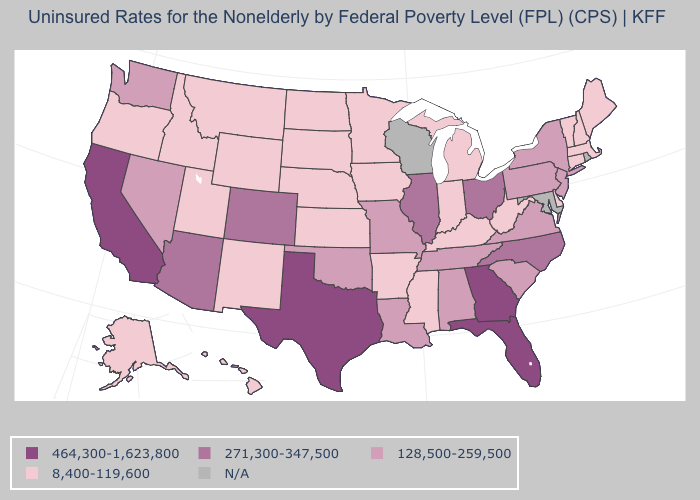What is the lowest value in states that border Oregon?
Answer briefly. 8,400-119,600. Name the states that have a value in the range 8,400-119,600?
Be succinct. Alaska, Arkansas, Connecticut, Delaware, Hawaii, Idaho, Indiana, Iowa, Kansas, Kentucky, Maine, Massachusetts, Michigan, Minnesota, Mississippi, Montana, Nebraska, New Hampshire, New Mexico, North Dakota, Oregon, South Dakota, Utah, Vermont, West Virginia, Wyoming. Among the states that border South Carolina , which have the highest value?
Keep it brief. Georgia. Among the states that border New York , which have the highest value?
Quick response, please. New Jersey, Pennsylvania. What is the value of South Dakota?
Keep it brief. 8,400-119,600. Does Colorado have the highest value in the USA?
Write a very short answer. No. Name the states that have a value in the range 128,500-259,500?
Short answer required. Alabama, Louisiana, Missouri, Nevada, New Jersey, New York, Oklahoma, Pennsylvania, South Carolina, Tennessee, Virginia, Washington. What is the value of Delaware?
Answer briefly. 8,400-119,600. What is the value of Kansas?
Keep it brief. 8,400-119,600. Does the first symbol in the legend represent the smallest category?
Short answer required. No. Which states have the lowest value in the MidWest?
Short answer required. Indiana, Iowa, Kansas, Michigan, Minnesota, Nebraska, North Dakota, South Dakota. What is the value of Connecticut?
Be succinct. 8,400-119,600. Does the map have missing data?
Keep it brief. Yes. What is the value of Massachusetts?
Short answer required. 8,400-119,600. What is the value of South Carolina?
Quick response, please. 128,500-259,500. 